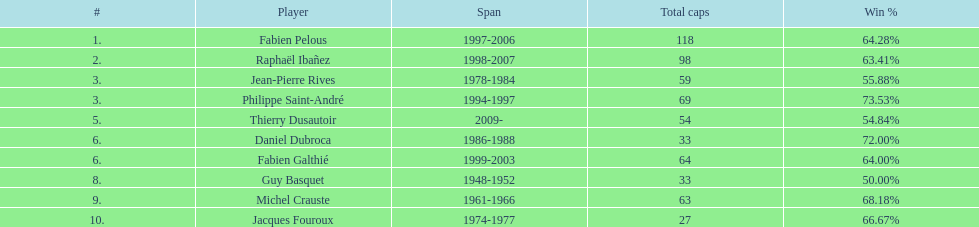How many years did fabien pelous hold the captain position in the french national rugby team? 9 years. 